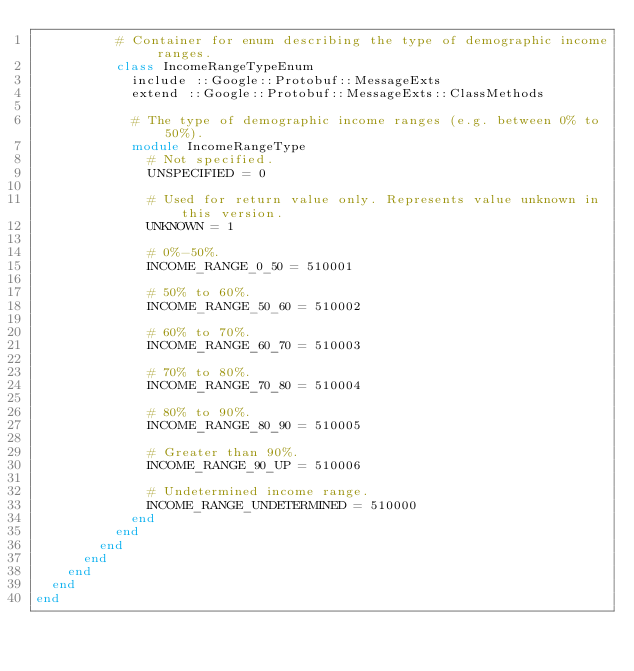<code> <loc_0><loc_0><loc_500><loc_500><_Ruby_>          # Container for enum describing the type of demographic income ranges.
          class IncomeRangeTypeEnum
            include ::Google::Protobuf::MessageExts
            extend ::Google::Protobuf::MessageExts::ClassMethods

            # The type of demographic income ranges (e.g. between 0% to 50%).
            module IncomeRangeType
              # Not specified.
              UNSPECIFIED = 0

              # Used for return value only. Represents value unknown in this version.
              UNKNOWN = 1

              # 0%-50%.
              INCOME_RANGE_0_50 = 510001

              # 50% to 60%.
              INCOME_RANGE_50_60 = 510002

              # 60% to 70%.
              INCOME_RANGE_60_70 = 510003

              # 70% to 80%.
              INCOME_RANGE_70_80 = 510004

              # 80% to 90%.
              INCOME_RANGE_80_90 = 510005

              # Greater than 90%.
              INCOME_RANGE_90_UP = 510006

              # Undetermined income range.
              INCOME_RANGE_UNDETERMINED = 510000
            end
          end
        end
      end
    end
  end
end
</code> 